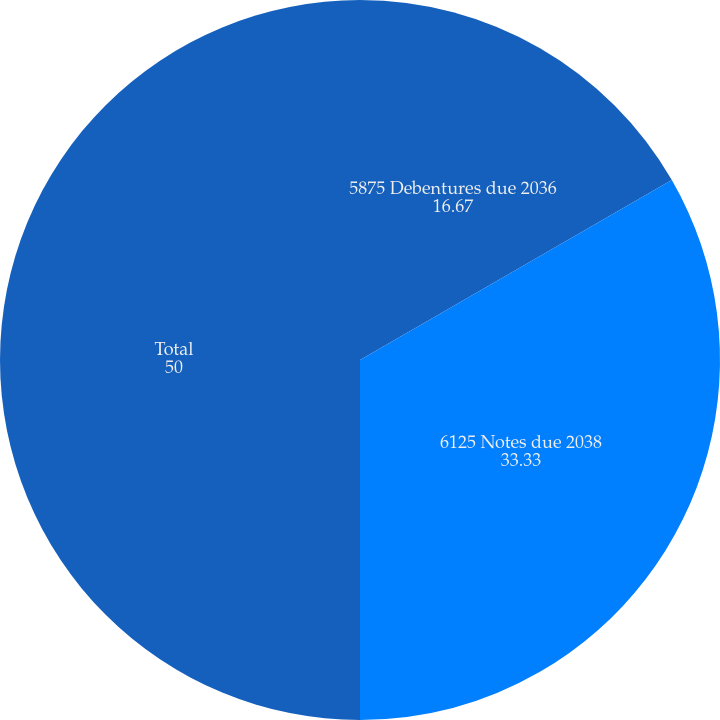Convert chart. <chart><loc_0><loc_0><loc_500><loc_500><pie_chart><fcel>5875 Debentures due 2036<fcel>6125 Notes due 2038<fcel>Total<nl><fcel>16.67%<fcel>33.33%<fcel>50.0%<nl></chart> 